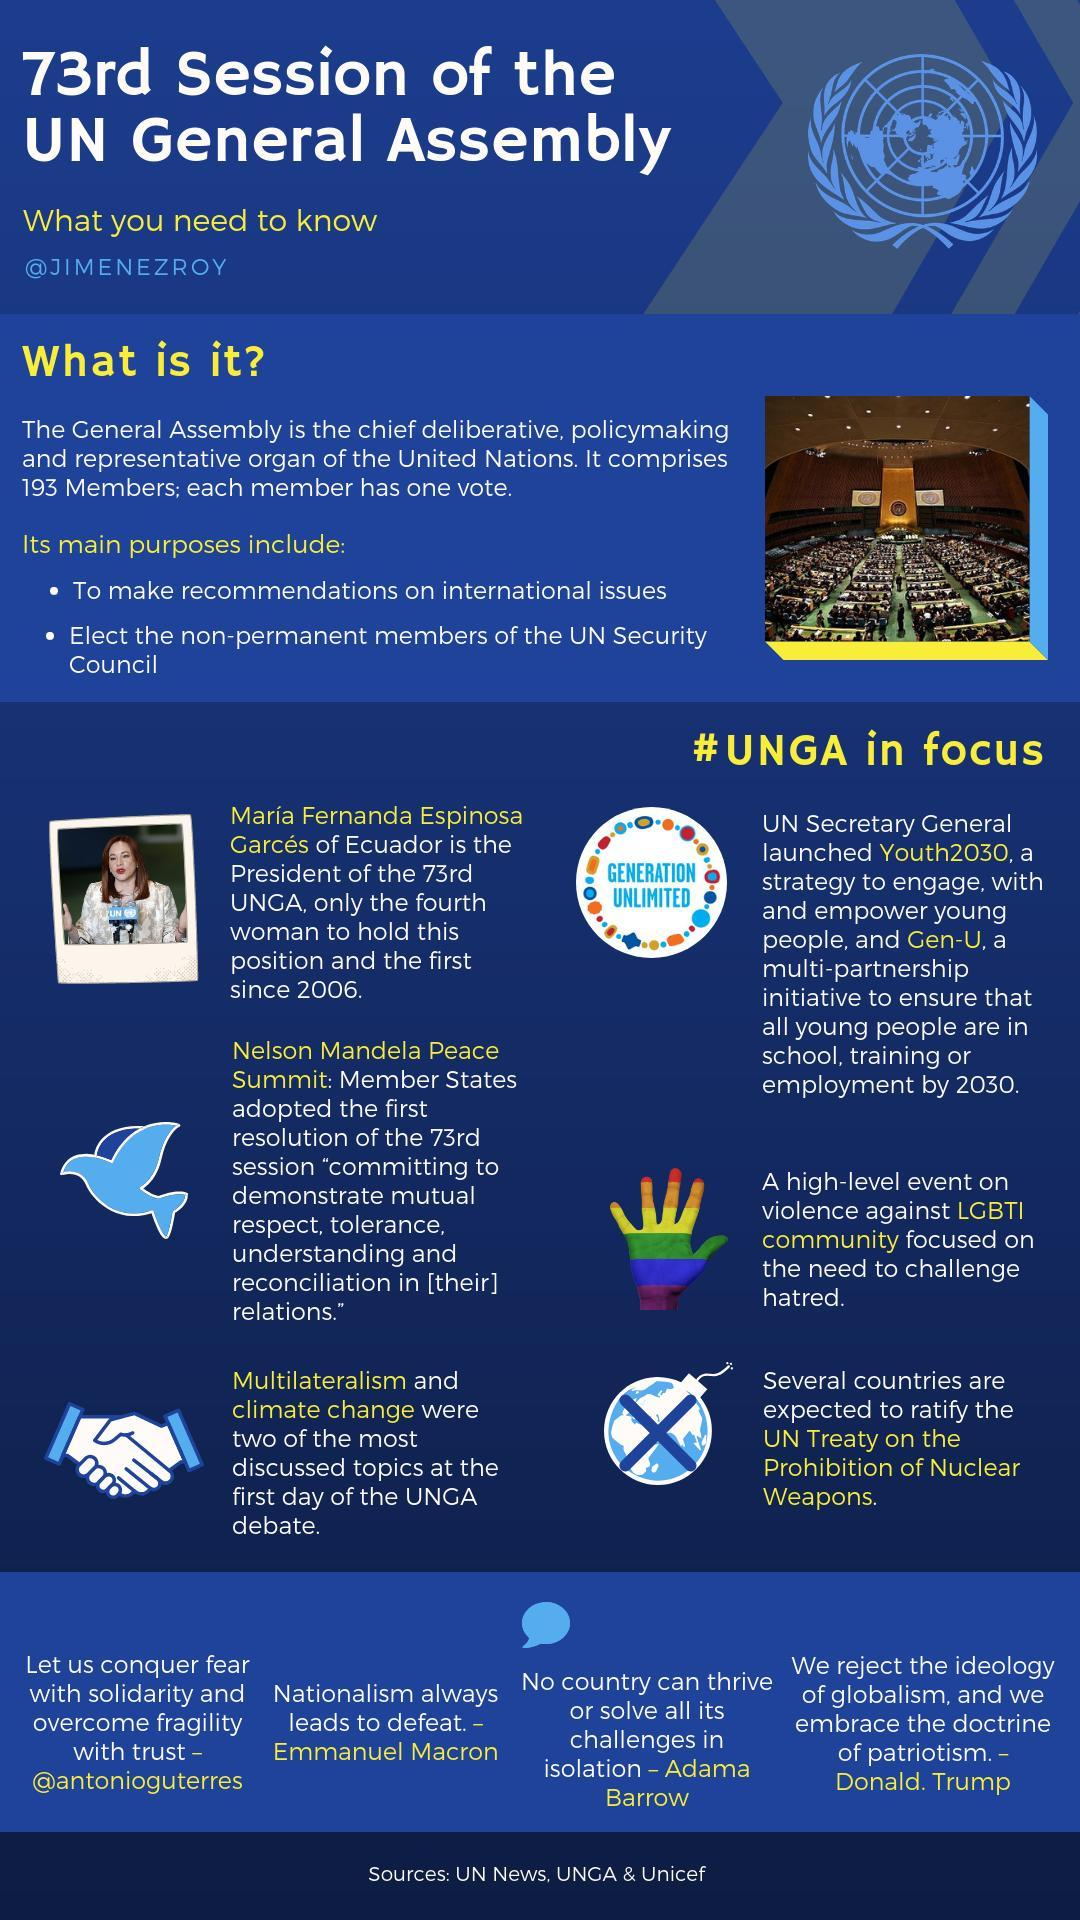What does UNGA stand for?
Answer the question with a short phrase. UN General Assembly What is the target year for Youth2030 and Gen-U? 2030 